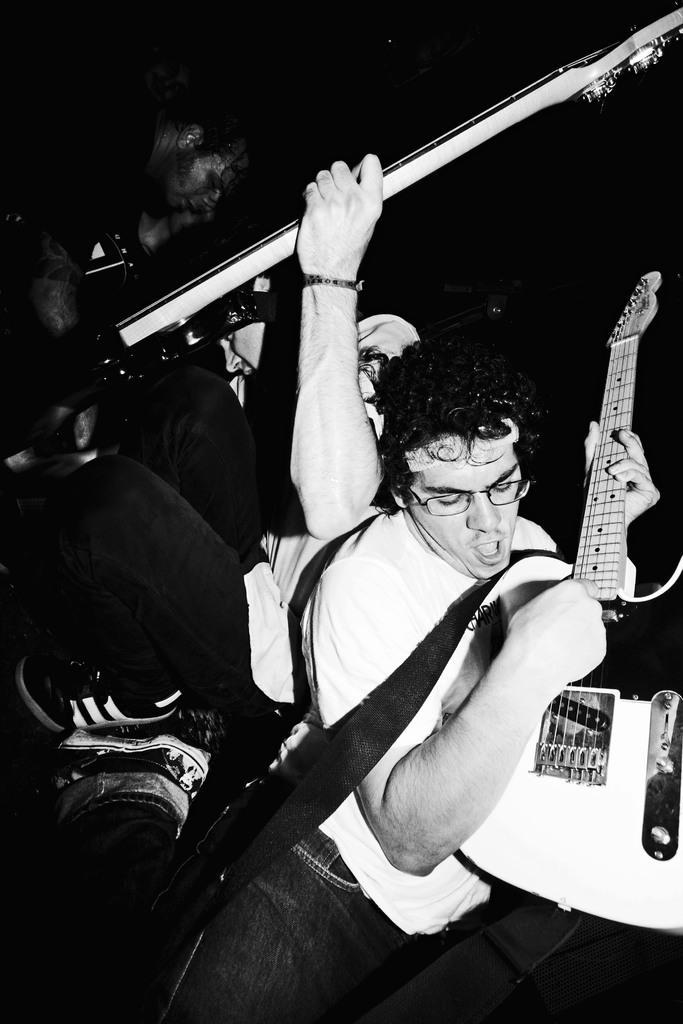In one or two sentences, can you explain what this image depicts? In this image i can see a person holding a guitar on his hand , his mouth and wearing a spectacles and back side of him there is a another person holding a rod on his hand. 